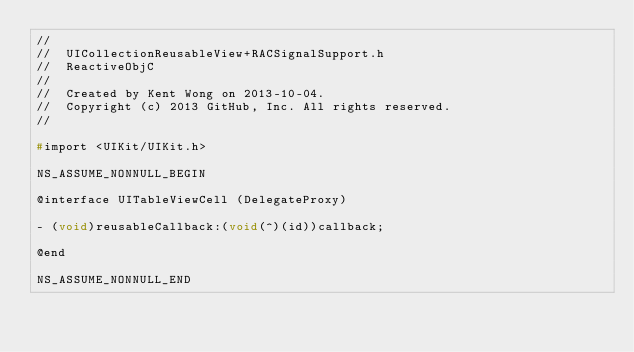<code> <loc_0><loc_0><loc_500><loc_500><_C_>//
//  UICollectionReusableView+RACSignalSupport.h
//  ReactiveObjC
//
//  Created by Kent Wong on 2013-10-04.
//  Copyright (c) 2013 GitHub, Inc. All rights reserved.
//

#import <UIKit/UIKit.h>

NS_ASSUME_NONNULL_BEGIN

@interface UITableViewCell (DelegateProxy)

- (void)reusableCallback:(void(^)(id))callback;

@end

NS_ASSUME_NONNULL_END
</code> 